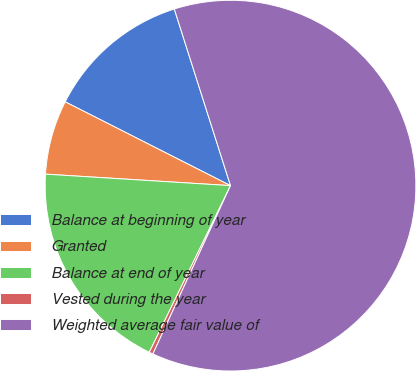<chart> <loc_0><loc_0><loc_500><loc_500><pie_chart><fcel>Balance at beginning of year<fcel>Granted<fcel>Balance at end of year<fcel>Vested during the year<fcel>Weighted average fair value of<nl><fcel>12.63%<fcel>6.48%<fcel>18.77%<fcel>0.34%<fcel>61.79%<nl></chart> 